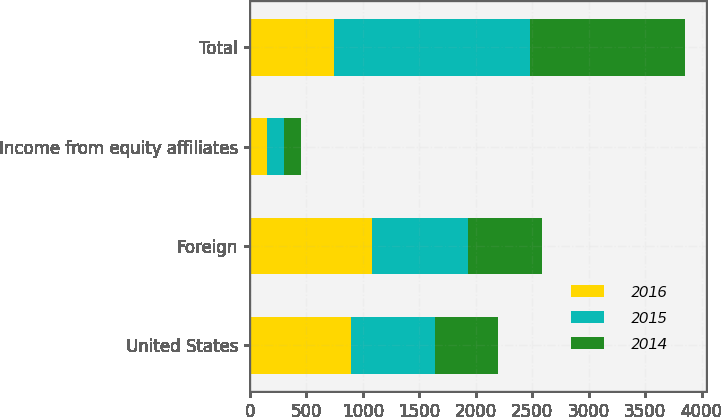Convert chart. <chart><loc_0><loc_0><loc_500><loc_500><stacked_bar_chart><ecel><fcel>United States<fcel>Foreign<fcel>Income from equity affiliates<fcel>Total<nl><fcel>2016<fcel>897.5<fcel>1086.1<fcel>148.6<fcel>742<nl><fcel>2015<fcel>742<fcel>846.2<fcel>154.5<fcel>1742.7<nl><fcel>2014<fcel>562.2<fcel>651.8<fcel>151.4<fcel>1365.4<nl></chart> 